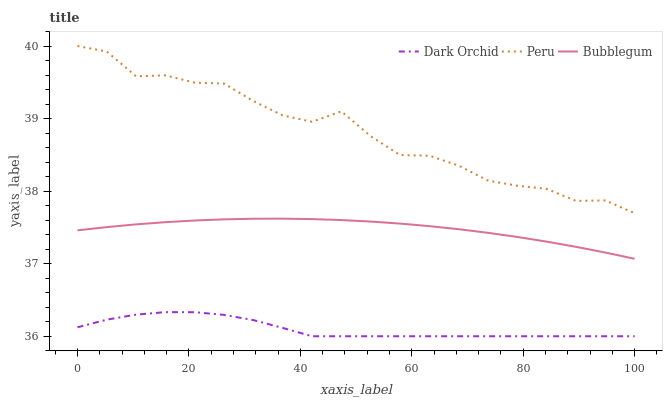Does Dark Orchid have the minimum area under the curve?
Answer yes or no. Yes. Does Peru have the maximum area under the curve?
Answer yes or no. Yes. Does Peru have the minimum area under the curve?
Answer yes or no. No. Does Dark Orchid have the maximum area under the curve?
Answer yes or no. No. Is Bubblegum the smoothest?
Answer yes or no. Yes. Is Peru the roughest?
Answer yes or no. Yes. Is Dark Orchid the smoothest?
Answer yes or no. No. Is Dark Orchid the roughest?
Answer yes or no. No. Does Peru have the lowest value?
Answer yes or no. No. Does Peru have the highest value?
Answer yes or no. Yes. Does Dark Orchid have the highest value?
Answer yes or no. No. Is Bubblegum less than Peru?
Answer yes or no. Yes. Is Bubblegum greater than Dark Orchid?
Answer yes or no. Yes. Does Bubblegum intersect Peru?
Answer yes or no. No. 